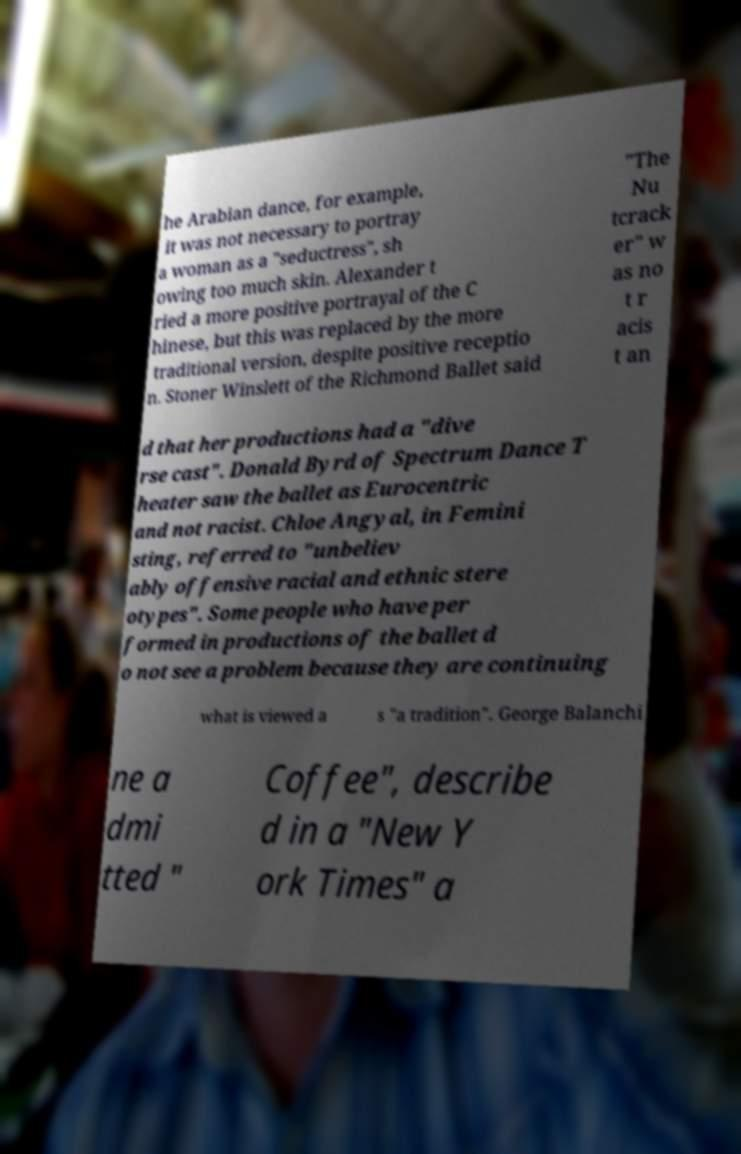I need the written content from this picture converted into text. Can you do that? he Arabian dance, for example, it was not necessary to portray a woman as a "seductress", sh owing too much skin. Alexander t ried a more positive portrayal of the C hinese, but this was replaced by the more traditional version, despite positive receptio n. Stoner Winslett of the Richmond Ballet said "The Nu tcrack er" w as no t r acis t an d that her productions had a "dive rse cast". Donald Byrd of Spectrum Dance T heater saw the ballet as Eurocentric and not racist. Chloe Angyal, in Femini sting, referred to "unbeliev ably offensive racial and ethnic stere otypes". Some people who have per formed in productions of the ballet d o not see a problem because they are continuing what is viewed a s "a tradition". George Balanchi ne a dmi tted " Coffee", describe d in a "New Y ork Times" a 